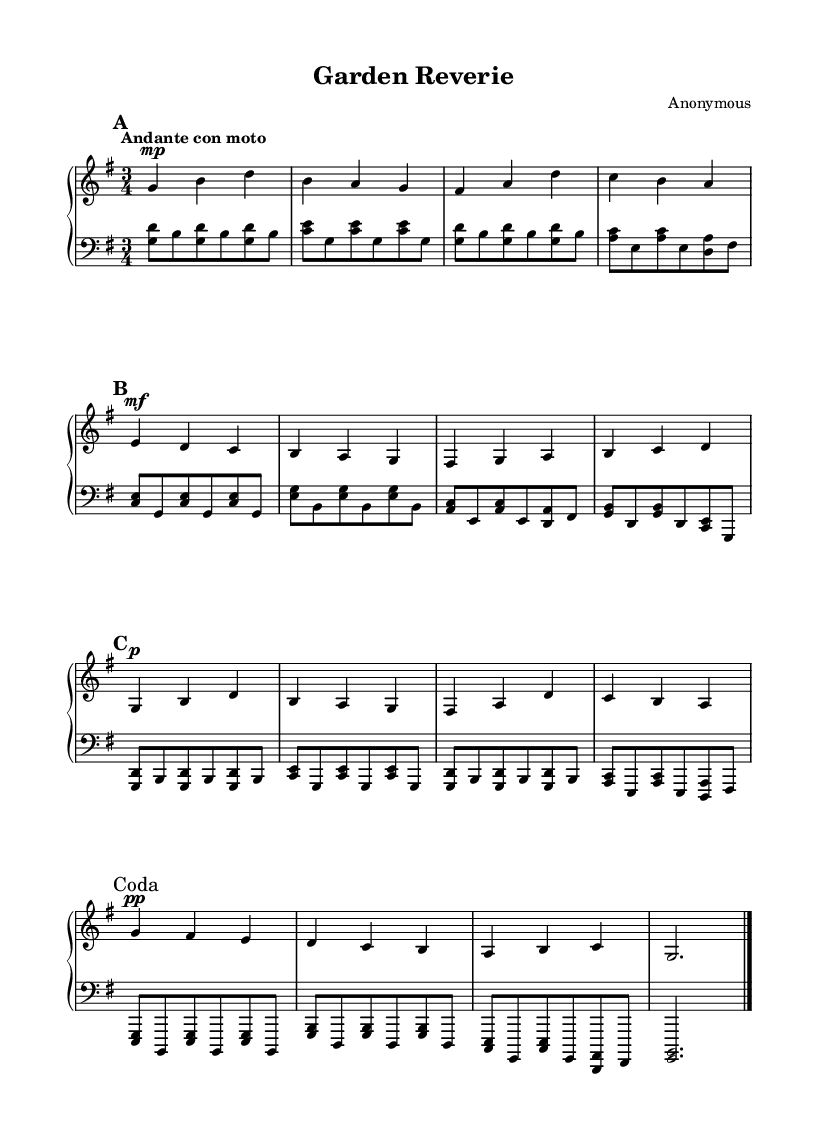What is the key signature of this music? The key signature is G major, which has one sharp (F#).
Answer: G major What is the time signature of this composition? The time signature is 3/4, indicating three beats per measure.
Answer: 3/4 What is the tempo marking for this piece? The tempo marking is "Andante con moto," which suggests a moderate speed with some movement.
Answer: Andante con moto How many sections does this piece have? The piece has three main sections: A, B, and A', followed by a coda.
Answer: Three What is the dynamic marking for the first section? The dynamic marking for the first section is "mp," indicating a moderately soft volume.
Answer: mp What is the final dynamic marking at the coda? The final dynamic marking at the coda is "pp," which means pianississimo or very soft.
Answer: pp Which section features a contrasting dynamic marked as "mf"? The B section features a contrasting dynamic marked as "mf," indicating a moderate loudness compared to the other sections.
Answer: B section 